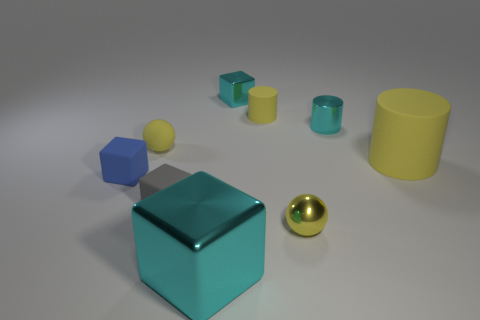Subtract all tiny rubber cylinders. How many cylinders are left? 2 Subtract 1 cylinders. How many cylinders are left? 2 Subtract all gray blocks. How many blocks are left? 3 Subtract all red blocks. Subtract all gray spheres. How many blocks are left? 4 Subtract all small red rubber cylinders. Subtract all tiny yellow rubber cylinders. How many objects are left? 8 Add 4 big cyan metallic cubes. How many big cyan metallic cubes are left? 5 Add 3 big things. How many big things exist? 5 Subtract 0 blue cylinders. How many objects are left? 9 Subtract all blocks. How many objects are left? 5 